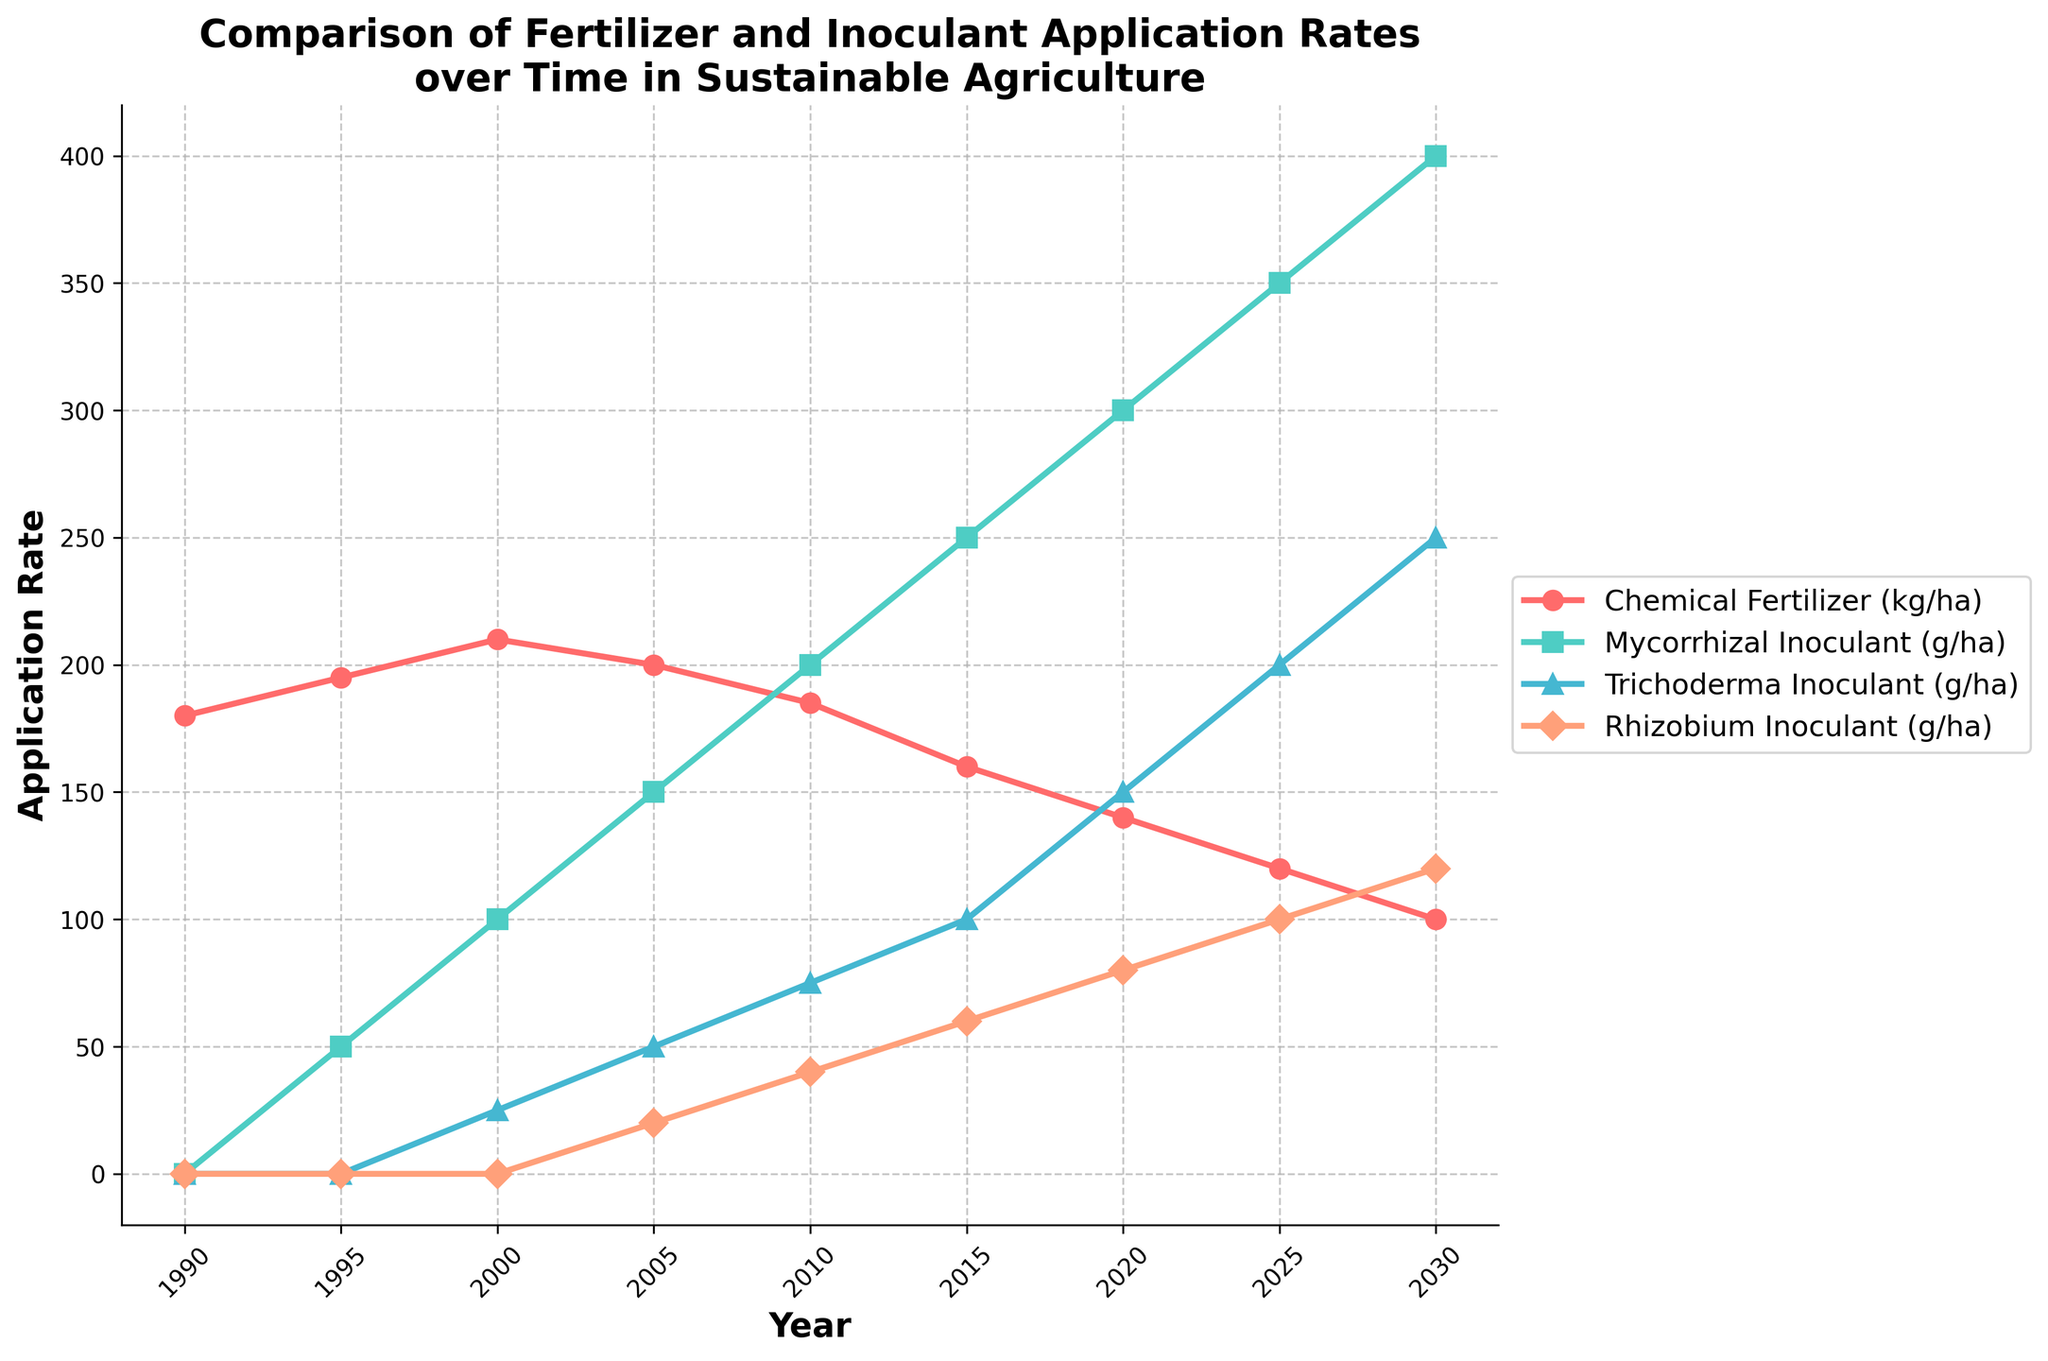Which year had the highest application rate of chemical fertilizer? In the figure, trace the line representing chemical fertilizer and identify the year with the highest point.
Answer: 2000 How much did the application rate of chemical fertilizer decrease from 2000 to 2020? Locate the points for chemical fertilizer in 2000 and 2020. Subtract the value at 2020 from the value at 2000: 210 - 140 = 70.
Answer: 70 kg/ha Compare the application rates of Trichoderma inoculant and Rhizobium inoculant in 2010. Which was higher and by how much? Identify the points for Trichoderma and Rhizobium inoculants in 2010. Compare the values: Trichoderma (75) and Rhizobium (40). Subtract the smaller from the larger: 75 - 40 = 35. Trichoderma is higher by 35 g/ha.
Answer: Trichoderma by 35 g/ha What is the overall trend in the application rate of mycorrhizal inoculant from 1990 to 2030? Observe the trend line for mycorrhizal inoculant: it steadily increases from 0 in 1990 to 400 in 2030.
Answer: Increasing Calculate the average application rate of Rhizobium inoculant from 2000 to 2030. Sum the Rhizobium inoculant values from 2000 to 2030: (0 + 20 + 40 + 60 + 80 + 100 + 120) = 420. There are 7 points, so the average is 420 / 7 = 60.
Answer: 60 g/ha Which year marks the first introduction of mycorrhizal inoculant application? Find the first non-zero point on the mycorrhizal inoculant line. This occurs in 1995.
Answer: 1995 From 2015 to 2025, by how much did the application rate of mycorrhizal inoculant increase? Identify the points for mycorrhizal inoculant in 2015 and 2025. Subtract the value at 2015 from the value at 2025: 350 - 250 = 100.
Answer: 100 g/ha What is the difference in application rate between chemical fertilizer and mycorrhizal inoculant in 2030? Locate the points for chemical fertilizer and mycorrhizal inoculant in 2030. Subtract the smaller value from the larger: 400 - 100 = 300.
Answer: 300 g/ha In which year does the application rate of Trichoderma inoculant first reach 100 g/ha? Identify the point where the Trichoderma inoculant line reaches 100 for the first time. This happens in 2015.
Answer: 2015 What is the visual trend for the application rates of chemical fertilizer and mycorrhizal inoculant over the entire period? The chemical fertilizer line shows a downward trend, while the mycorrhizal inoculant line shows an upward trend.
Answer: Chemical fertilizer decreases, mycorrhizal inoculant increases 